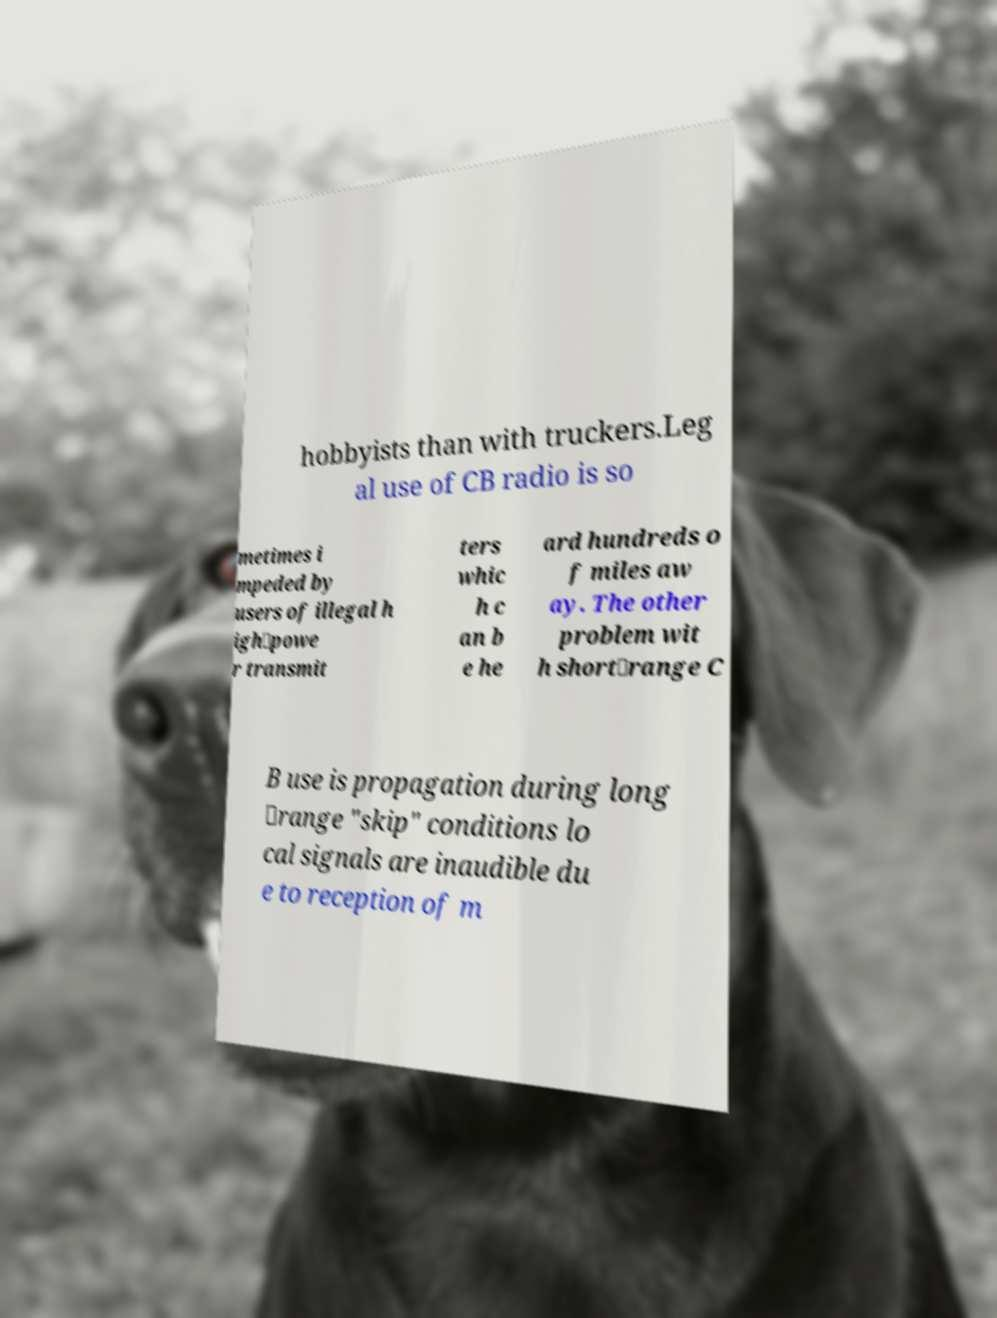There's text embedded in this image that I need extracted. Can you transcribe it verbatim? hobbyists than with truckers.Leg al use of CB radio is so metimes i mpeded by users of illegal h igh‑powe r transmit ters whic h c an b e he ard hundreds o f miles aw ay. The other problem wit h short‑range C B use is propagation during long ‑range "skip" conditions lo cal signals are inaudible du e to reception of m 